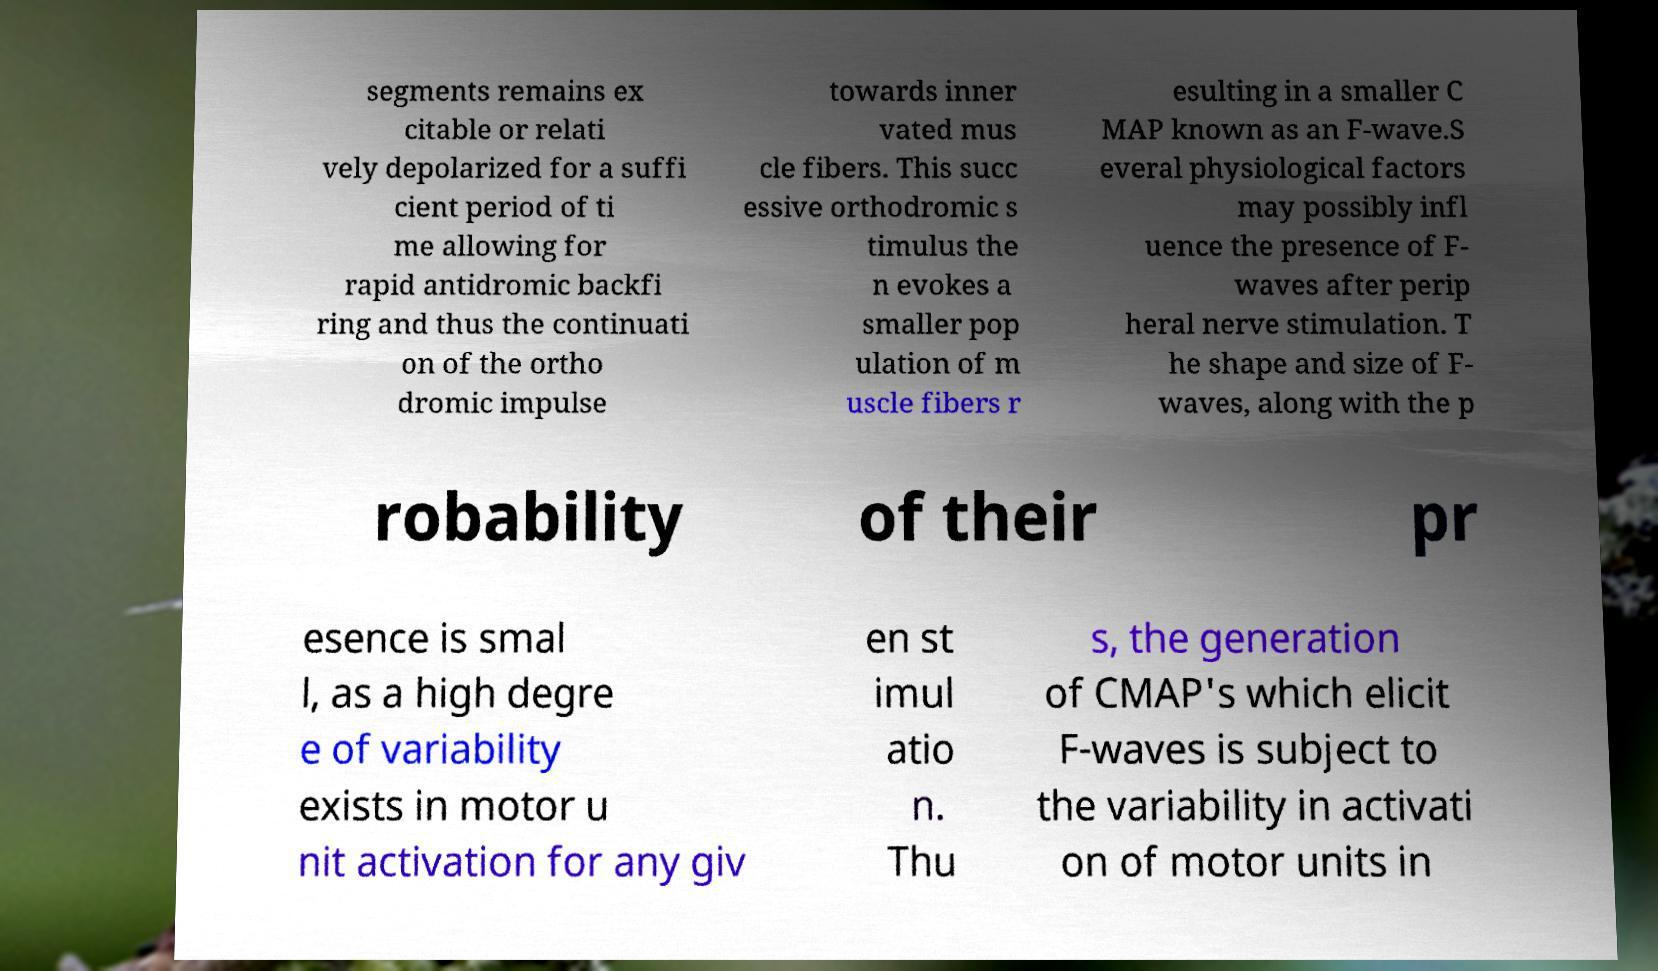Can you accurately transcribe the text from the provided image for me? segments remains ex citable or relati vely depolarized for a suffi cient period of ti me allowing for rapid antidromic backfi ring and thus the continuati on of the ortho dromic impulse towards inner vated mus cle fibers. This succ essive orthodromic s timulus the n evokes a smaller pop ulation of m uscle fibers r esulting in a smaller C MAP known as an F-wave.S everal physiological factors may possibly infl uence the presence of F- waves after perip heral nerve stimulation. T he shape and size of F- waves, along with the p robability of their pr esence is smal l, as a high degre e of variability exists in motor u nit activation for any giv en st imul atio n. Thu s, the generation of CMAP's which elicit F-waves is subject to the variability in activati on of motor units in 